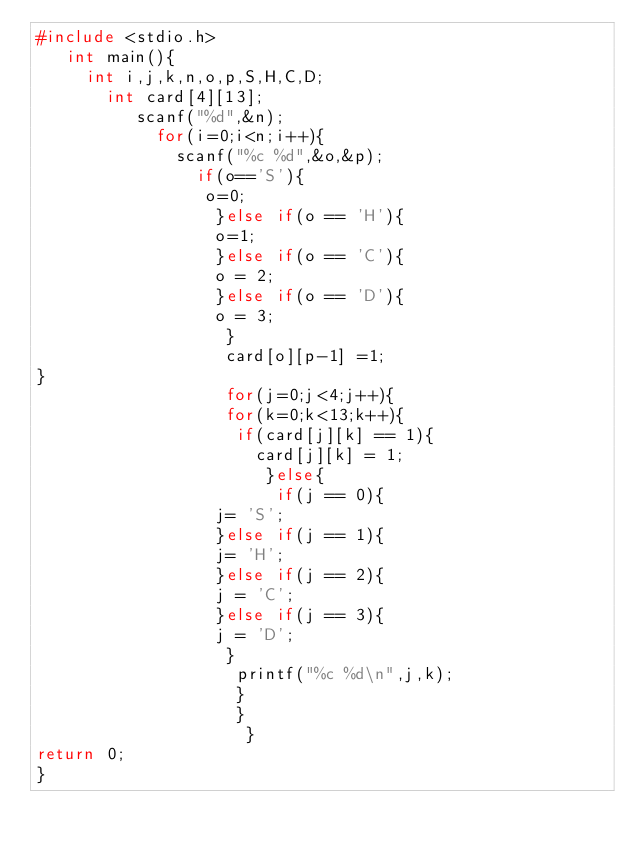<code> <loc_0><loc_0><loc_500><loc_500><_C_>#include <stdio.h>
   int main(){
     int i,j,k,n,o,p,S,H,C,D;
       int card[4][13];
          scanf("%d",&n);
            for(i=0;i<n;i++){
              scanf("%c %d",&o,&p);
                if(o=='S'){
                 o=0;
                  }else if(o == 'H'){
                  o=1;
                  }else if(o == 'C'){
                  o = 2;
                  }else if(o == 'D'){
                  o = 3;
                   }
                   card[o][p-1] =1;
}
                   for(j=0;j<4;j++){
                   for(k=0;k<13;k++){
                    if(card[j][k] == 1){
                      card[j][k] = 1;
                       }else{
                        if(j == 0){
                  j= 'S';
                  }else if(j == 1){
                  j= 'H';
                  }else if(j == 2){
                  j = 'C';
                  }else if(j == 3){
                  j = 'D';
                   }
                    printf("%c %d\n",j,k);
                    }
                    }
                     }
return 0;
} </code> 